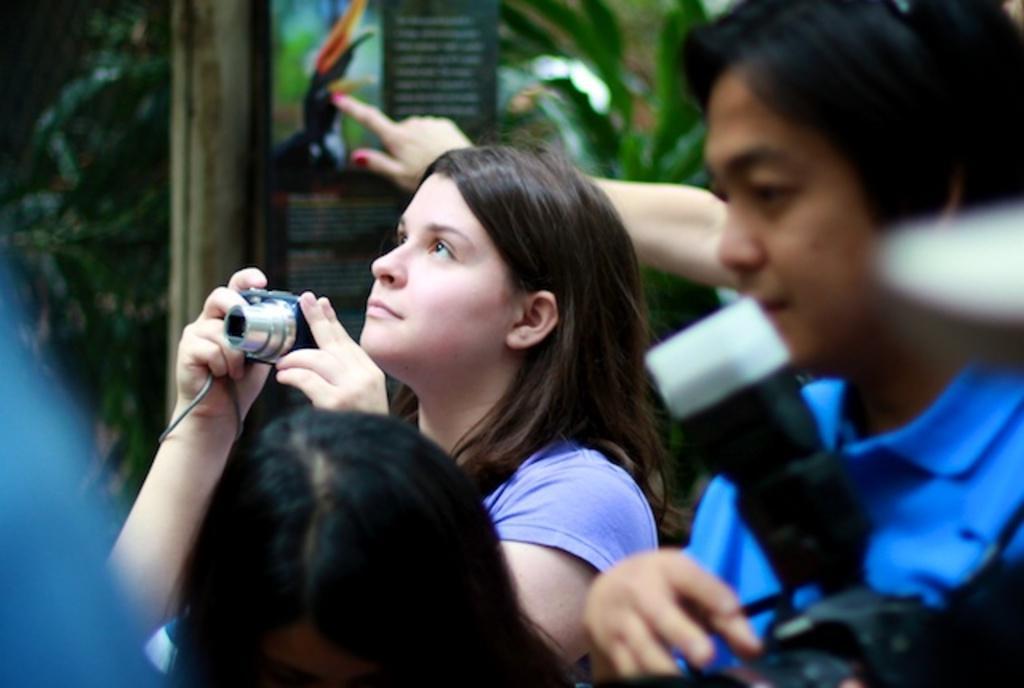How would you summarize this image in a sentence or two? In this image I can see few people and here I can see two of them are holding cameras. In background I can see a board and on it I can see something is written. I can also see this image is little bit blurry from background. 